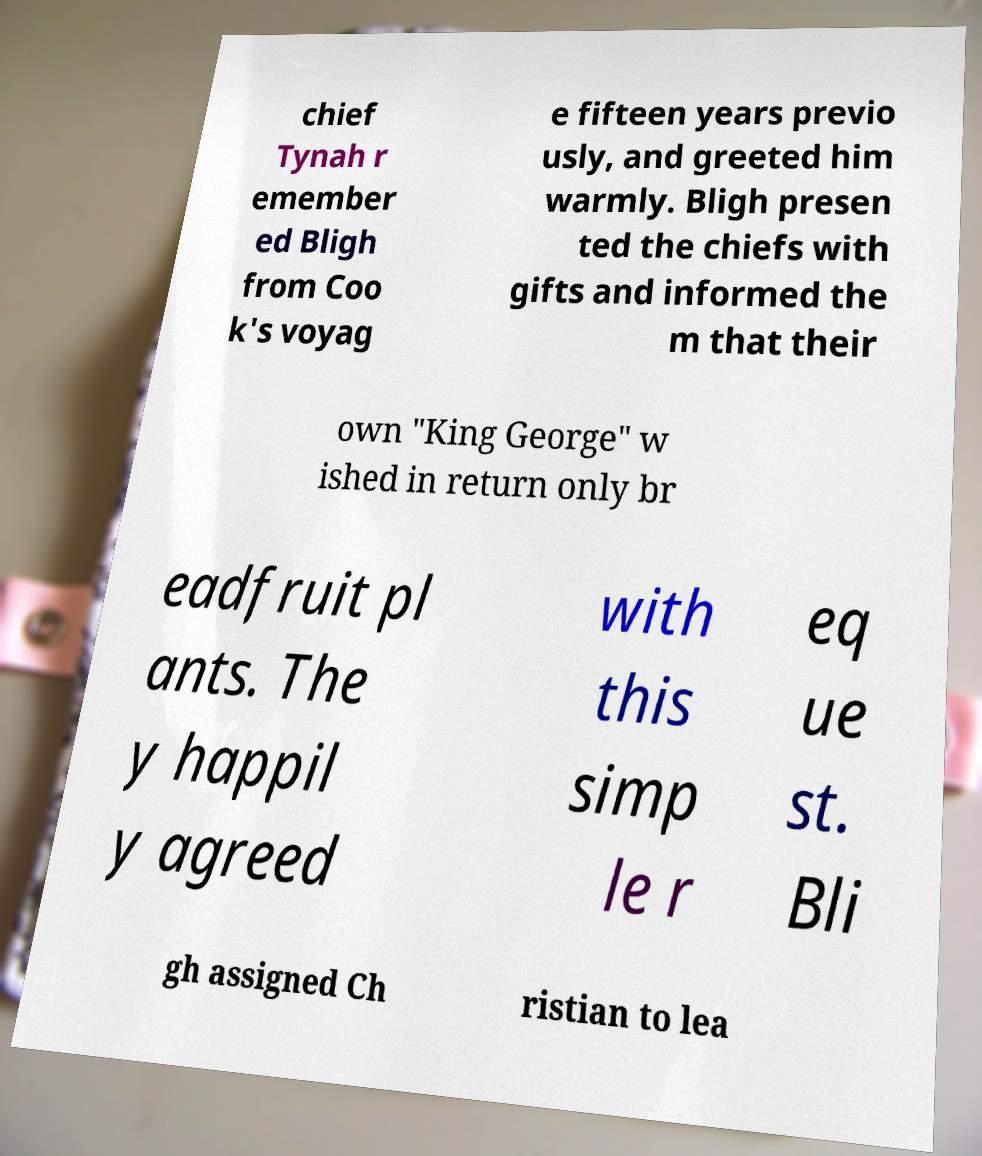Please identify and transcribe the text found in this image. chief Tynah r emember ed Bligh from Coo k's voyag e fifteen years previo usly, and greeted him warmly. Bligh presen ted the chiefs with gifts and informed the m that their own "King George" w ished in return only br eadfruit pl ants. The y happil y agreed with this simp le r eq ue st. Bli gh assigned Ch ristian to lea 